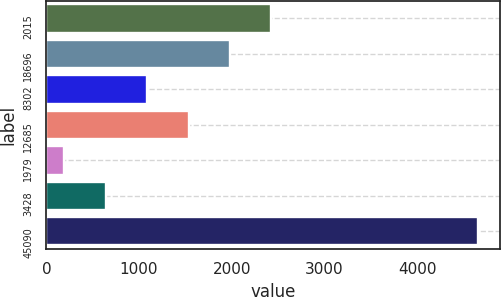<chart> <loc_0><loc_0><loc_500><loc_500><bar_chart><fcel>2015<fcel>18696<fcel>8302<fcel>12685<fcel>1979<fcel>3428<fcel>45090<nl><fcel>2427.95<fcel>1981.34<fcel>1088.12<fcel>1534.73<fcel>194.9<fcel>641.51<fcel>4661<nl></chart> 